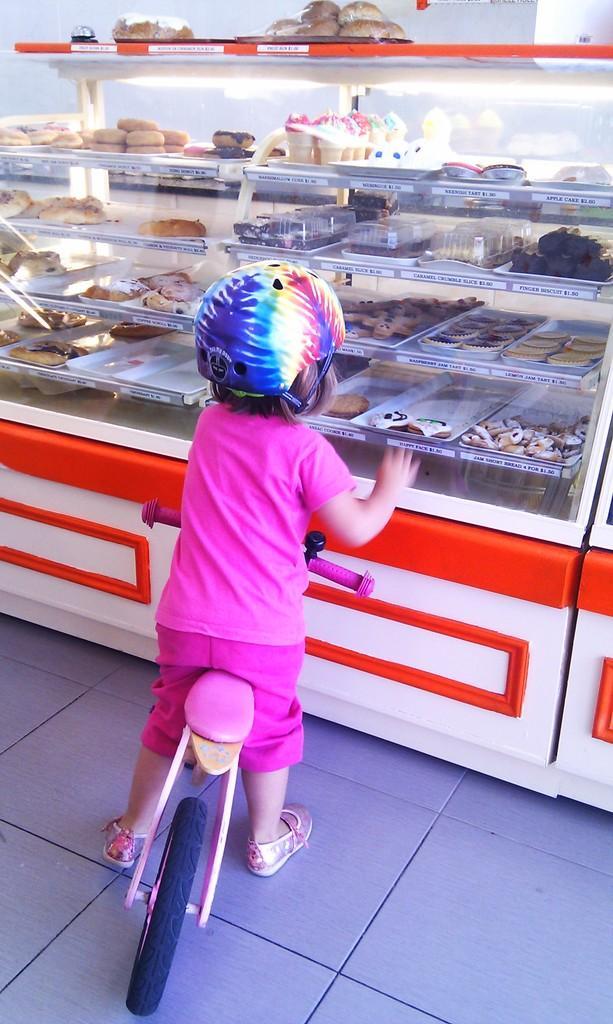In one or two sentences, can you explain what this image depicts? In this picture I can observe a small kid sitting on the bicycle. This kid is wearing pink color dress and helmet on her head. She is standing in front of some bakery food items. 